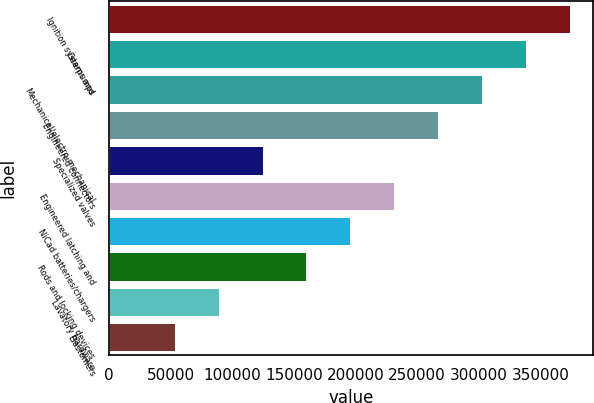<chart> <loc_0><loc_0><loc_500><loc_500><bar_chart><fcel>Ignition systems and<fcel>Gearpumps<fcel>Mechanical/electro-mechanical<fcel>Engineered connectors<fcel>Specialized valves<fcel>Engineered latching and<fcel>NiCad batteries/chargers<fcel>Rods and locking devices<fcel>Lavatory hardware<fcel>Elastomers<nl><fcel>374253<fcel>338560<fcel>302866<fcel>267173<fcel>124400<fcel>231480<fcel>195786<fcel>160093<fcel>88706.6<fcel>53013.3<nl></chart> 